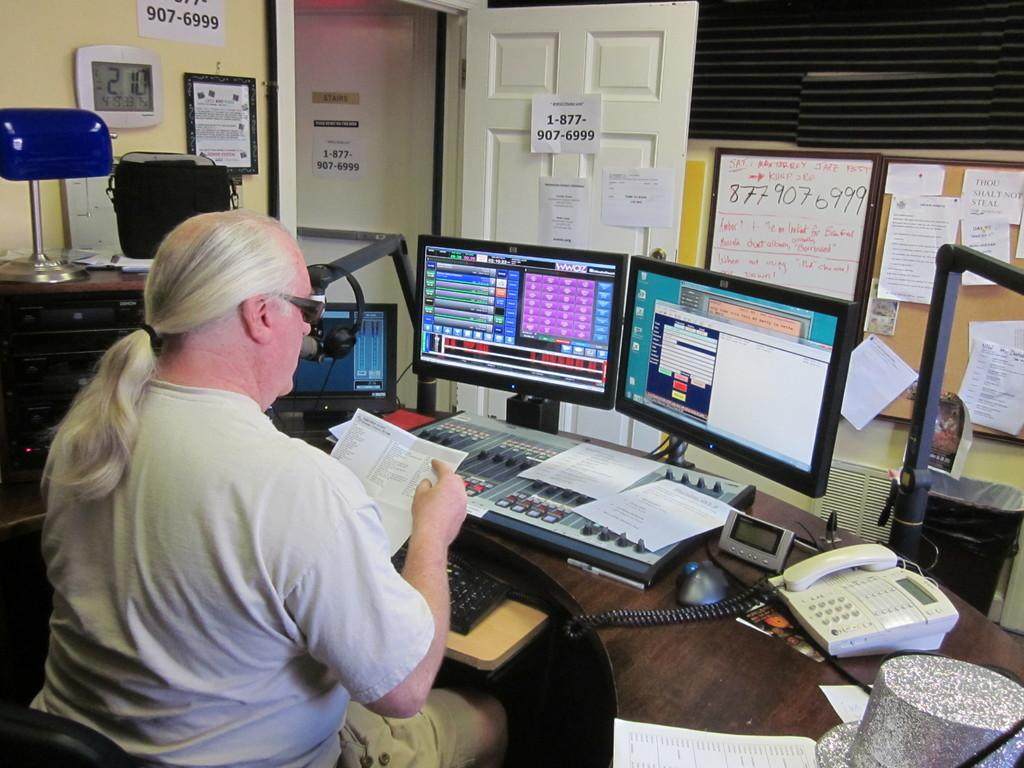<image>
Share a concise interpretation of the image provided. the number 1 is on a paper on the door with a phone number 